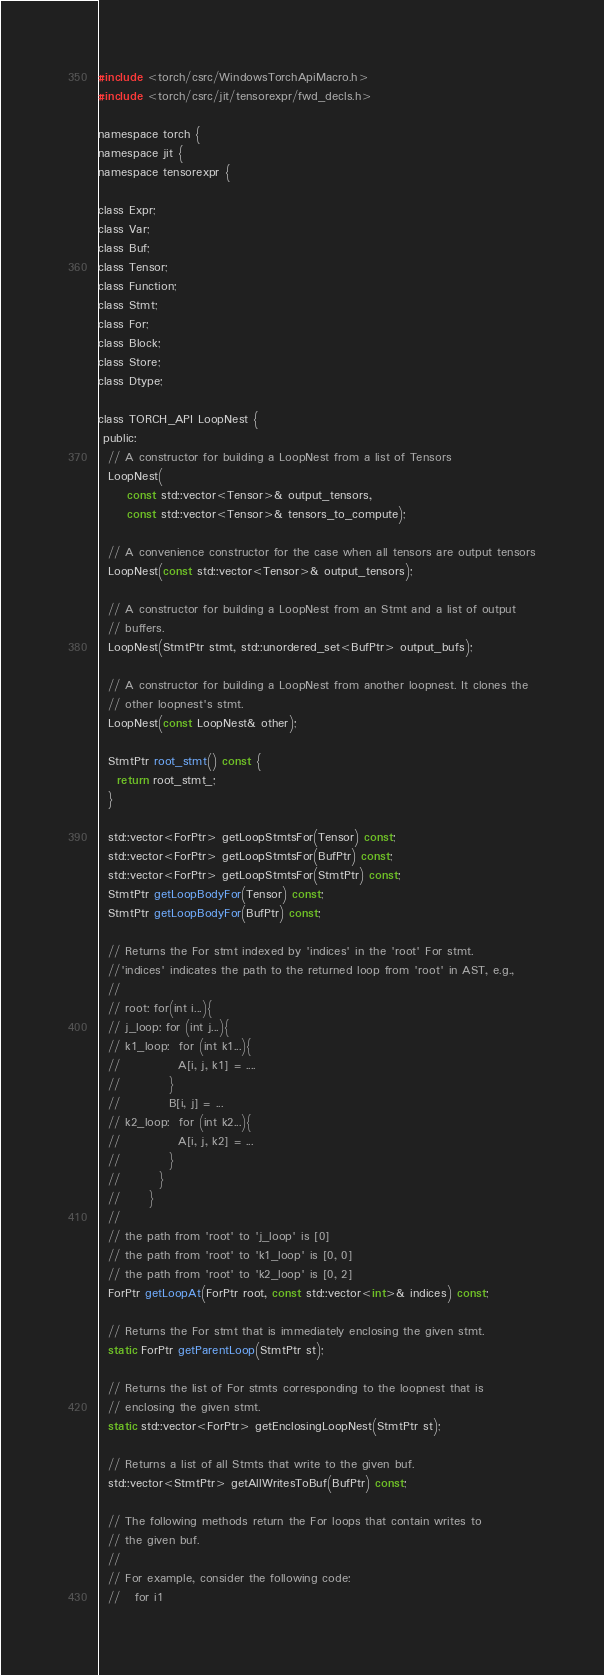Convert code to text. <code><loc_0><loc_0><loc_500><loc_500><_C_>
#include <torch/csrc/WindowsTorchApiMacro.h>
#include <torch/csrc/jit/tensorexpr/fwd_decls.h>

namespace torch {
namespace jit {
namespace tensorexpr {

class Expr;
class Var;
class Buf;
class Tensor;
class Function;
class Stmt;
class For;
class Block;
class Store;
class Dtype;

class TORCH_API LoopNest {
 public:
  // A constructor for building a LoopNest from a list of Tensors
  LoopNest(
      const std::vector<Tensor>& output_tensors,
      const std::vector<Tensor>& tensors_to_compute);

  // A convenience constructor for the case when all tensors are output tensors
  LoopNest(const std::vector<Tensor>& output_tensors);

  // A constructor for building a LoopNest from an Stmt and a list of output
  // buffers.
  LoopNest(StmtPtr stmt, std::unordered_set<BufPtr> output_bufs);

  // A constructor for building a LoopNest from another loopnest. It clones the
  // other loopnest's stmt.
  LoopNest(const LoopNest& other);

  StmtPtr root_stmt() const {
    return root_stmt_;
  }

  std::vector<ForPtr> getLoopStmtsFor(Tensor) const;
  std::vector<ForPtr> getLoopStmtsFor(BufPtr) const;
  std::vector<ForPtr> getLoopStmtsFor(StmtPtr) const;
  StmtPtr getLoopBodyFor(Tensor) const;
  StmtPtr getLoopBodyFor(BufPtr) const;

  // Returns the For stmt indexed by 'indices' in the 'root' For stmt.
  //'indices' indicates the path to the returned loop from 'root' in AST, e.g.,
  //
  // root: for(int i...){
  // j_loop: for (int j...){
  // k1_loop:  for (int k1...){
  //            A[i, j, k1] = ....
  //          }
  //          B[i, j] = ...
  // k2_loop:  for (int k2...){
  //            A[i, j, k2] = ...
  //          }
  //        }
  //      }
  //
  // the path from 'root' to 'j_loop' is [0]
  // the path from 'root' to 'k1_loop' is [0, 0]
  // the path from 'root' to 'k2_loop' is [0, 2]
  ForPtr getLoopAt(ForPtr root, const std::vector<int>& indices) const;

  // Returns the For stmt that is immediately enclosing the given stmt.
  static ForPtr getParentLoop(StmtPtr st);

  // Returns the list of For stmts corresponding to the loopnest that is
  // enclosing the given stmt.
  static std::vector<ForPtr> getEnclosingLoopNest(StmtPtr st);

  // Returns a list of all Stmts that write to the given buf.
  std::vector<StmtPtr> getAllWritesToBuf(BufPtr) const;

  // The following methods return the For loops that contain writes to
  // the given buf.
  //
  // For example, consider the following code:
  //   for i1</code> 